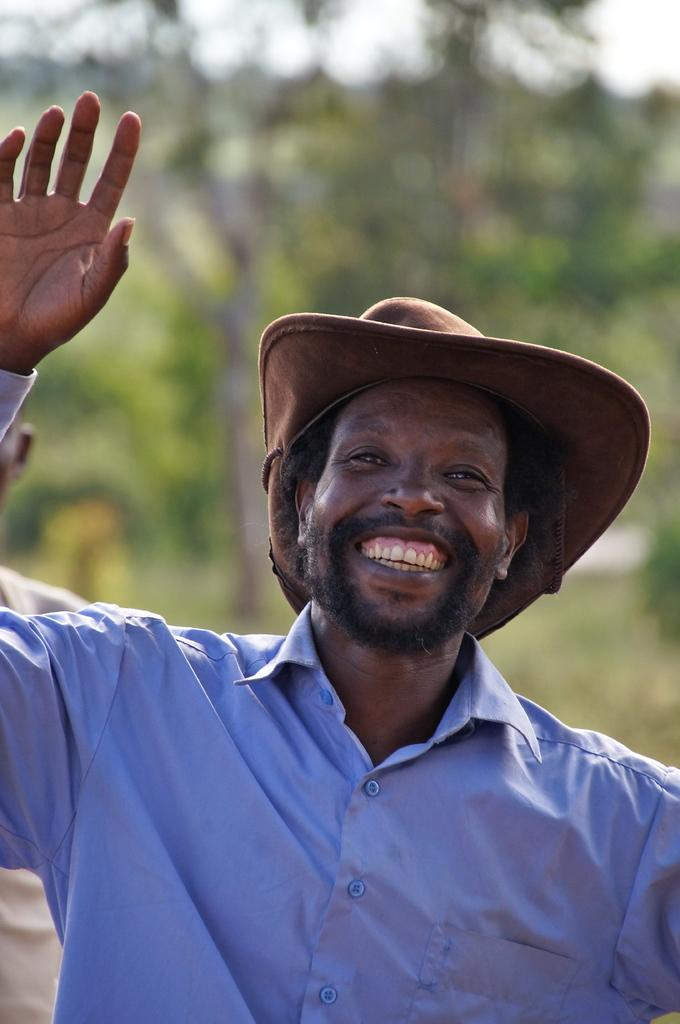What is the main subject of the image? The main subject of the image is a man. What is the man wearing in the image? The man is wearing a blue shirt in the image. What is the man's facial expression in the image? The man is smiling in the image. What is the man doing in the image? The man is giving a pose for the picture in the image. What can be seen in the background of the image? There are trees in the background of the image. What type of egg can be seen in the man's hand in the image? There is no egg present in the man's hand or in the image. 